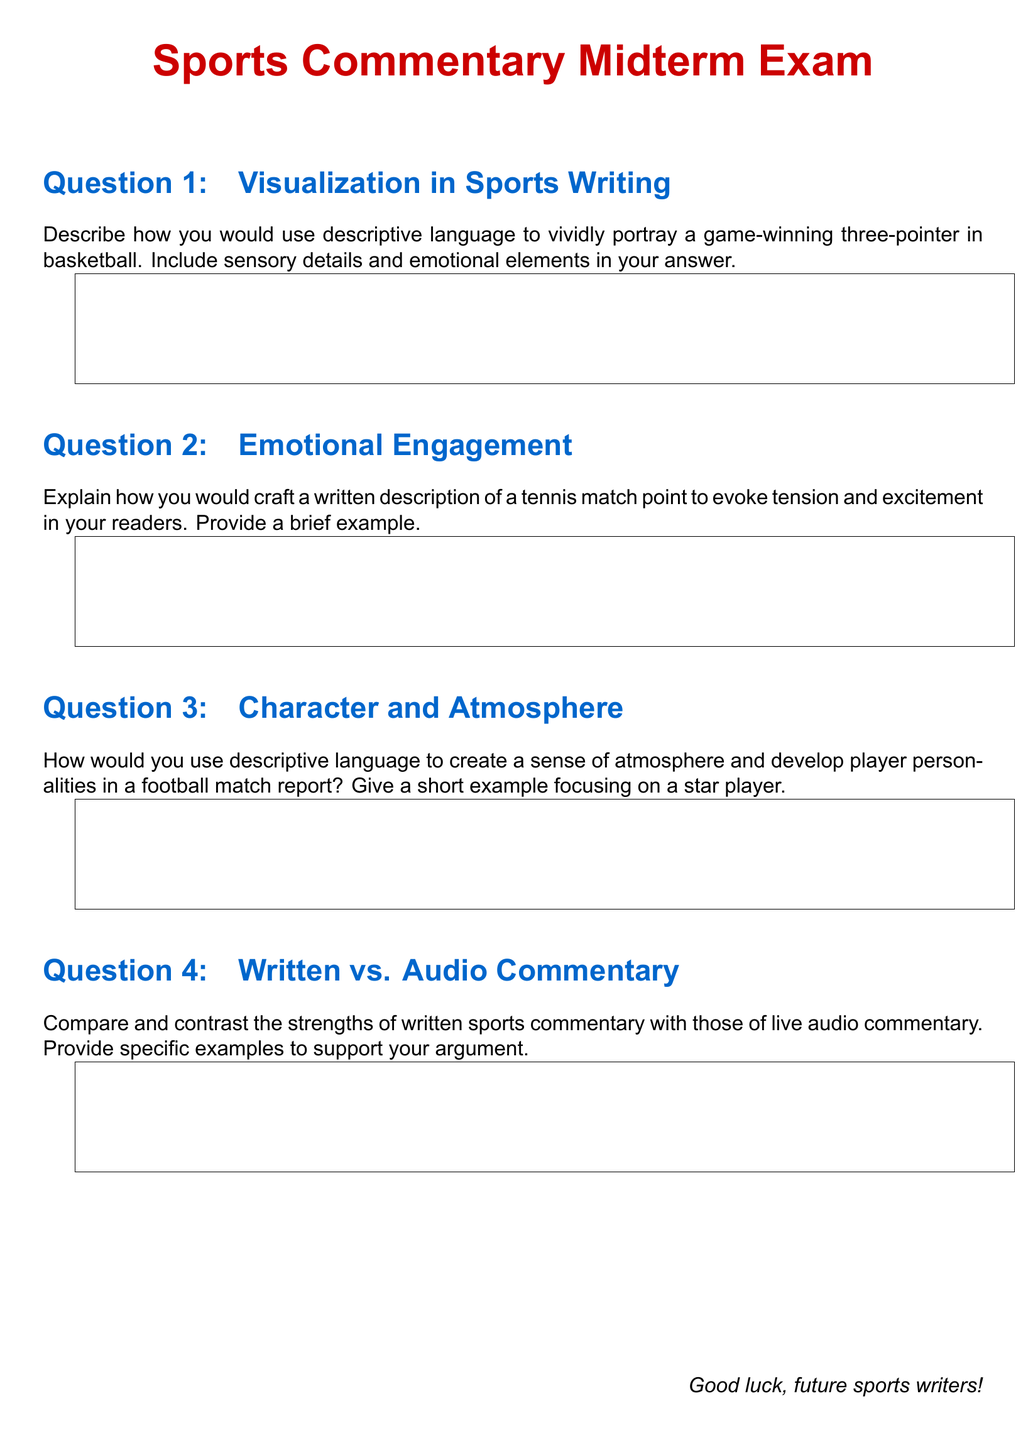What is the title of the document? The title of the document is presented at the top of the page, indicating the purpose of the document.
Answer: Sports Commentary Midterm Exam How many sections are in the midterm exam? The section titles indicate the number of distinct areas covered in the exam, which are listed clearly.
Answer: 4 What color is used for section titles? The color used for section titles is defined in the document to enhance its visual appeal.
Answer: Sporty blue What is the primary font used in this document? The document specifies a main font that is utilized throughout for text clarity and readability.
Answer: Arial What type of questions does the exam include? The document outlines the kinds of responses expected, which reflect the subject of the exam.
Answer: Short-answer questions Which sport is referenced in the visualization section? The specific sport is mentioned in the context of illustrating a critical game moment in the section description.
Answer: Basketball What emotional aspects are emphasized in the emotional engagement section? This section focuses on conveying feelings and excitement during a sports event to draw in the audience.
Answer: Tension and excitement What player focus is suggested in the character and atmosphere section? The guidelines presented in this section emphasize notable individuals in the context of a sports report.
Answer: Star player What type of commentary is compared in the written vs. audio section? This section contrasts two different methods of delivering sports commentary to highlight their unique strengths.
Answer: Written and live audio commentary 